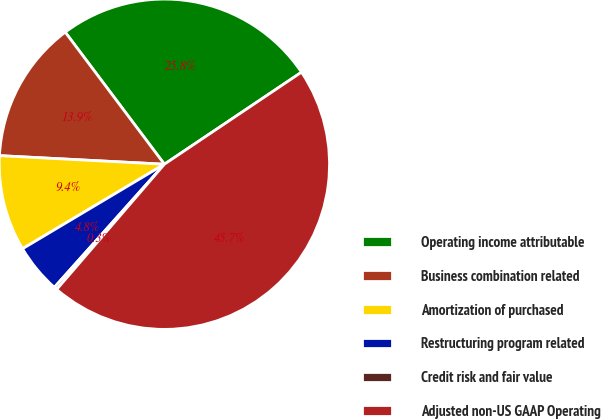Convert chart. <chart><loc_0><loc_0><loc_500><loc_500><pie_chart><fcel>Operating income attributable<fcel>Business combination related<fcel>Amortization of purchased<fcel>Restructuring program related<fcel>Credit risk and fair value<fcel>Adjusted non-US GAAP Operating<nl><fcel>25.84%<fcel>13.92%<fcel>9.38%<fcel>4.84%<fcel>0.3%<fcel>45.71%<nl></chart> 